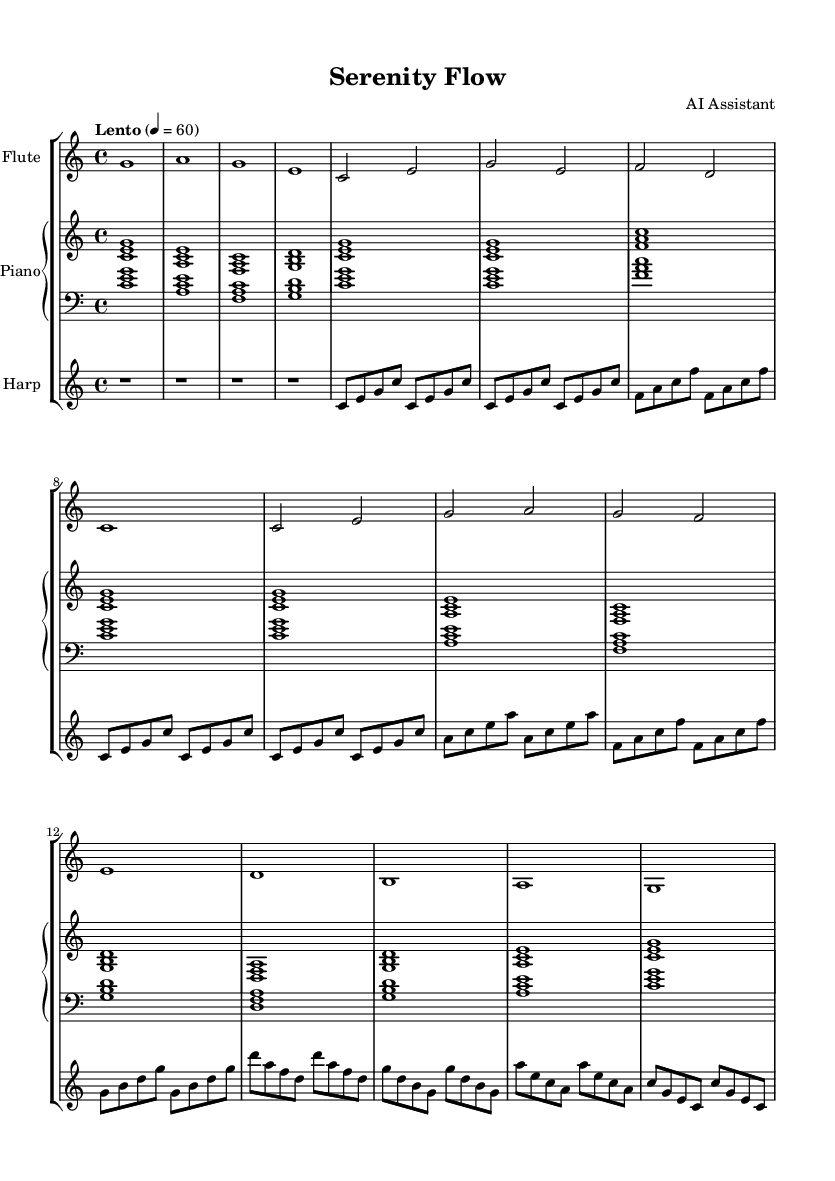What is the key signature of this music? The key signature is C major, which has no sharps or flats.
Answer: C major What is the time signature of this music? The time signature is indicated by the numbers at the beginning of the score, which shows there are four beats per measure with a quarter note getting one beat.
Answer: 4/4 What is the tempo marking for this piece? The tempo marking is found above the staff and indicates the pace of the music, where "Lento" means slowly, with a specific beats per minute value given as 60.
Answer: Lento How many measures does the flute part consist of? The flute part consists of a series of measure bars; by counting the bars, we can determine that there are a total of 8 measures in the flute section.
Answer: 8 Which instrument plays the highest notes in this score? By analyzing the parts for their octave ranges, the flute typically plays higher pitches than the piano and harp, which allows us to conclude that the flute plays the highest notes in this score.
Answer: Flute In which measure does the harp play the first note? The harp starts its part after four measures of rest and begins playing in measure 5, where it introduces its melodic lines.
Answer: Measure 5 What type of harmony is suggested by the piano part? The piano part features triads built on each beat indicating that it employs a harmonic style, primarily using major chords to create a pleasant and soothing texture fitting for meditation music.
Answer: Triadic harmony 